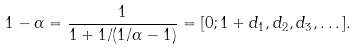Convert formula to latex. <formula><loc_0><loc_0><loc_500><loc_500>1 - \alpha = \frac { 1 } { 1 + 1 / ( 1 / \alpha - 1 ) } = [ 0 ; 1 + d _ { 1 } , d _ { 2 } , d _ { 3 } , \dots ] .</formula> 